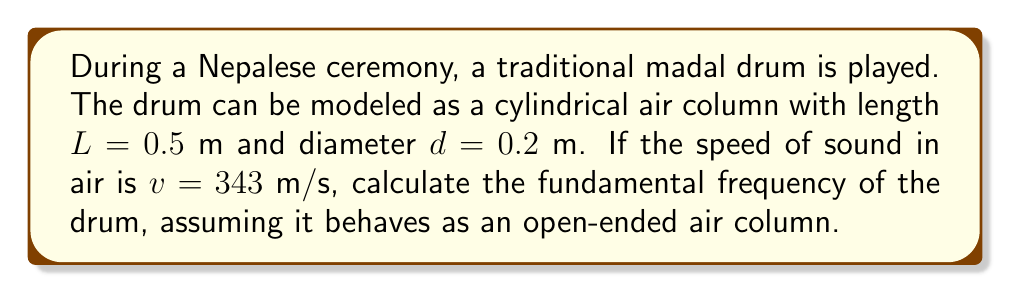Help me with this question. To solve this problem, we'll follow these steps:

1) For an open-ended air column, the fundamental frequency is given by the equation:

   $$f = \frac{v}{2L}$$

   Where:
   $f$ is the fundamental frequency
   $v$ is the speed of sound
   $L$ is the length of the air column

2) We are given:
   $v = 343$ m/s
   $L = 0.5$ m

3) Substituting these values into the equation:

   $$f = \frac{343}{2(0.5)}$$

4) Simplify:
   $$f = \frac{343}{1} = 343$$

5) Therefore, the fundamental frequency is 343 Hz.

Note: In reality, the madal drum is more complex than a simple open-ended air column, and its acoustic properties would depend on factors such as the tension of the drumheads and the material of the drum body. This model provides a simplified approximation for understanding the basic principles involved.
Answer: 343 Hz 